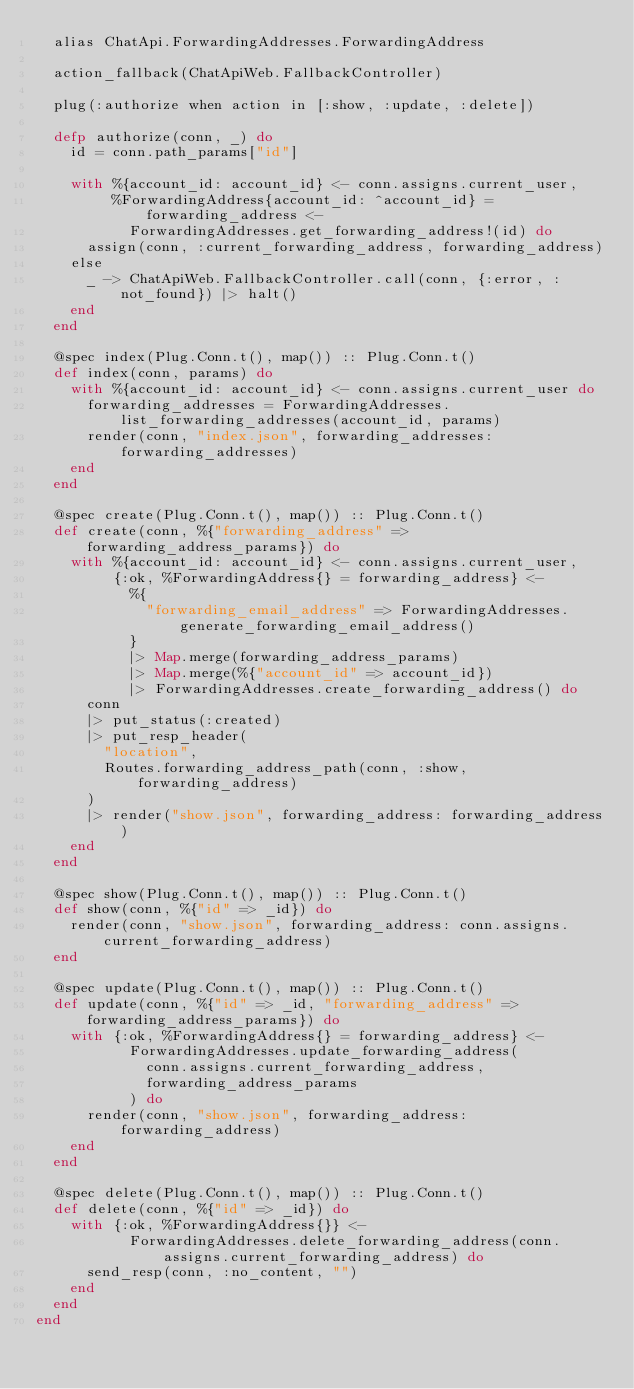Convert code to text. <code><loc_0><loc_0><loc_500><loc_500><_Elixir_>  alias ChatApi.ForwardingAddresses.ForwardingAddress

  action_fallback(ChatApiWeb.FallbackController)

  plug(:authorize when action in [:show, :update, :delete])

  defp authorize(conn, _) do
    id = conn.path_params["id"]

    with %{account_id: account_id} <- conn.assigns.current_user,
         %ForwardingAddress{account_id: ^account_id} = forwarding_address <-
           ForwardingAddresses.get_forwarding_address!(id) do
      assign(conn, :current_forwarding_address, forwarding_address)
    else
      _ -> ChatApiWeb.FallbackController.call(conn, {:error, :not_found}) |> halt()
    end
  end

  @spec index(Plug.Conn.t(), map()) :: Plug.Conn.t()
  def index(conn, params) do
    with %{account_id: account_id} <- conn.assigns.current_user do
      forwarding_addresses = ForwardingAddresses.list_forwarding_addresses(account_id, params)
      render(conn, "index.json", forwarding_addresses: forwarding_addresses)
    end
  end

  @spec create(Plug.Conn.t(), map()) :: Plug.Conn.t()
  def create(conn, %{"forwarding_address" => forwarding_address_params}) do
    with %{account_id: account_id} <- conn.assigns.current_user,
         {:ok, %ForwardingAddress{} = forwarding_address} <-
           %{
             "forwarding_email_address" => ForwardingAddresses.generate_forwarding_email_address()
           }
           |> Map.merge(forwarding_address_params)
           |> Map.merge(%{"account_id" => account_id})
           |> ForwardingAddresses.create_forwarding_address() do
      conn
      |> put_status(:created)
      |> put_resp_header(
        "location",
        Routes.forwarding_address_path(conn, :show, forwarding_address)
      )
      |> render("show.json", forwarding_address: forwarding_address)
    end
  end

  @spec show(Plug.Conn.t(), map()) :: Plug.Conn.t()
  def show(conn, %{"id" => _id}) do
    render(conn, "show.json", forwarding_address: conn.assigns.current_forwarding_address)
  end

  @spec update(Plug.Conn.t(), map()) :: Plug.Conn.t()
  def update(conn, %{"id" => _id, "forwarding_address" => forwarding_address_params}) do
    with {:ok, %ForwardingAddress{} = forwarding_address} <-
           ForwardingAddresses.update_forwarding_address(
             conn.assigns.current_forwarding_address,
             forwarding_address_params
           ) do
      render(conn, "show.json", forwarding_address: forwarding_address)
    end
  end

  @spec delete(Plug.Conn.t(), map()) :: Plug.Conn.t()
  def delete(conn, %{"id" => _id}) do
    with {:ok, %ForwardingAddress{}} <-
           ForwardingAddresses.delete_forwarding_address(conn.assigns.current_forwarding_address) do
      send_resp(conn, :no_content, "")
    end
  end
end
</code> 